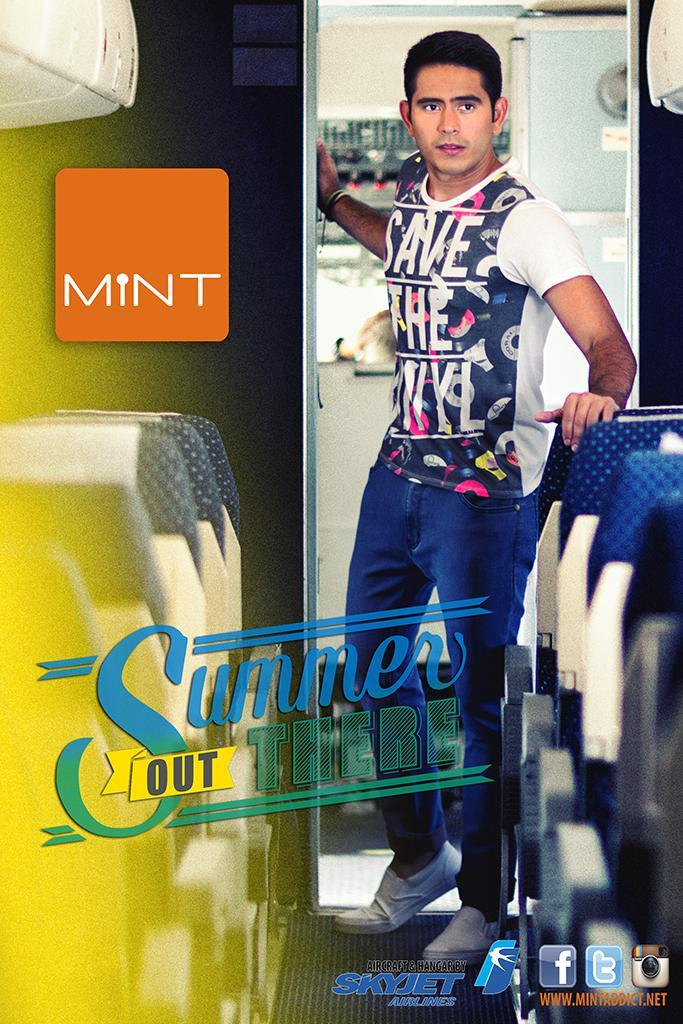<image>
Relay a brief, clear account of the picture shown. An advertisement for mint wants to save the summer. 